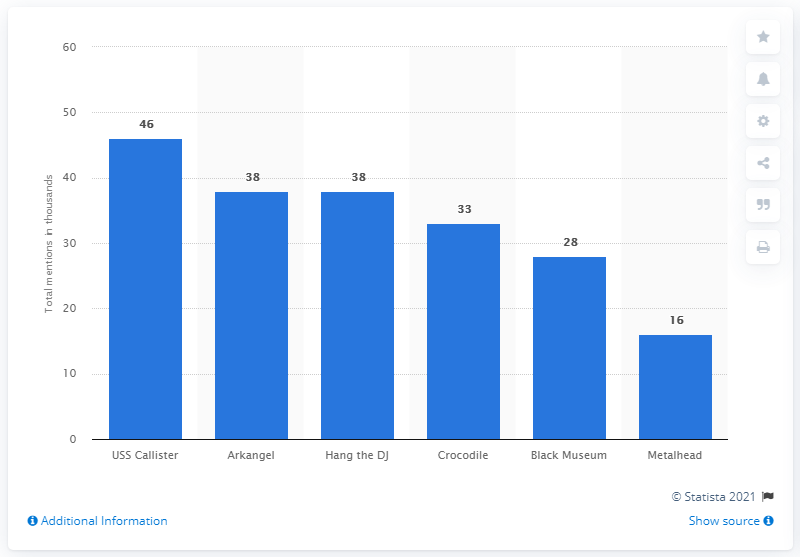Specify some key components in this picture. The episode of Black Mirror that received the highest number of mentions on Twitter was "USS Callister. 